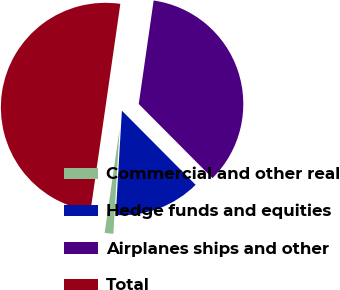Convert chart to OTSL. <chart><loc_0><loc_0><loc_500><loc_500><pie_chart><fcel>Commercial and other real<fcel>Hedge funds and equities<fcel>Airplanes ships and other<fcel>Total<nl><fcel>1.34%<fcel>13.39%<fcel>35.27%<fcel>50.0%<nl></chart> 